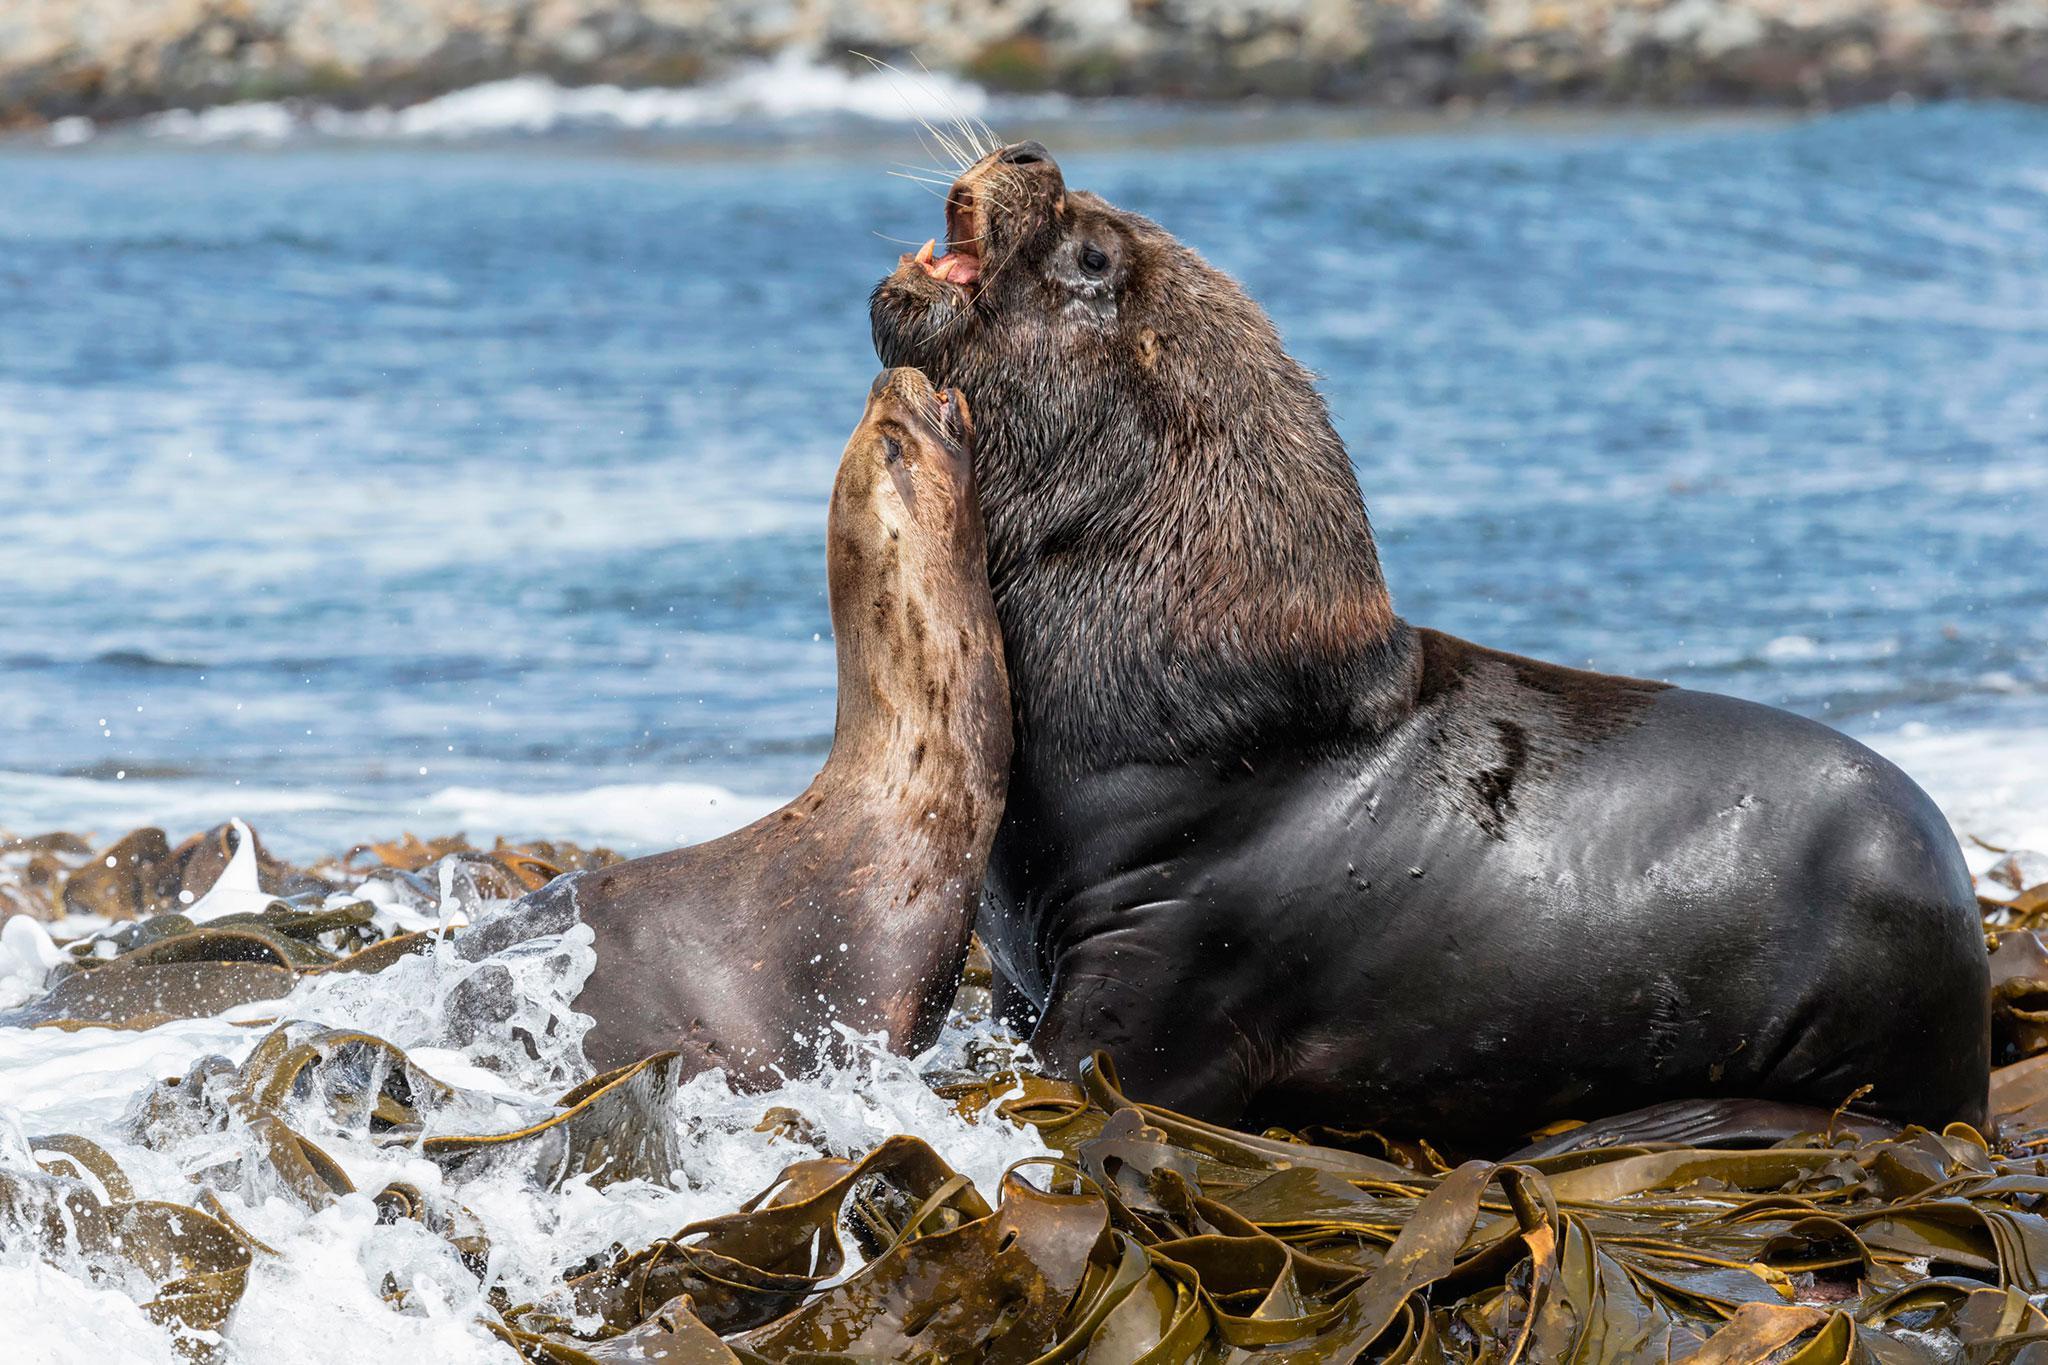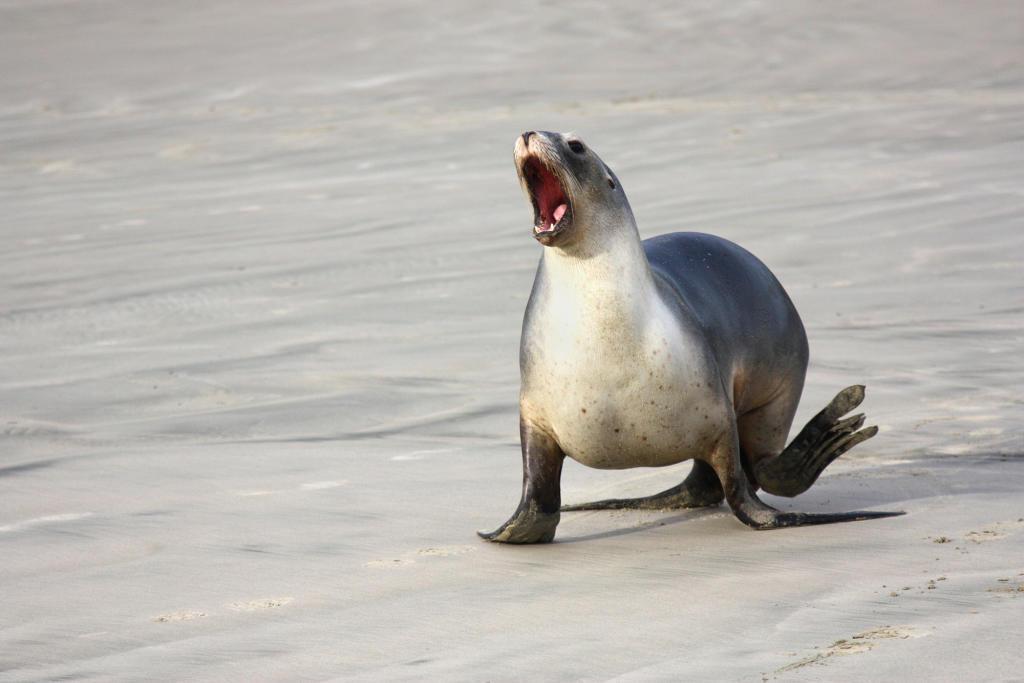The first image is the image on the left, the second image is the image on the right. Examine the images to the left and right. Is the description "there are two seals in the image on the right." accurate? Answer yes or no. No. The first image is the image on the left, the second image is the image on the right. For the images shown, is this caption "There are two sea lions facing left." true? Answer yes or no. Yes. The first image is the image on the left, the second image is the image on the right. Analyze the images presented: Is the assertion "There are two seals" valid? Answer yes or no. No. 